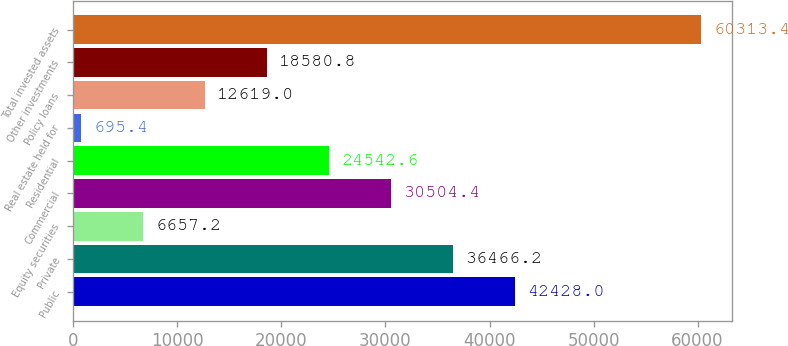<chart> <loc_0><loc_0><loc_500><loc_500><bar_chart><fcel>Public<fcel>Private<fcel>Equity securities<fcel>Commercial<fcel>Residential<fcel>Real estate held for<fcel>Policy loans<fcel>Other investments<fcel>Total invested assets<nl><fcel>42428<fcel>36466.2<fcel>6657.2<fcel>30504.4<fcel>24542.6<fcel>695.4<fcel>12619<fcel>18580.8<fcel>60313.4<nl></chart> 